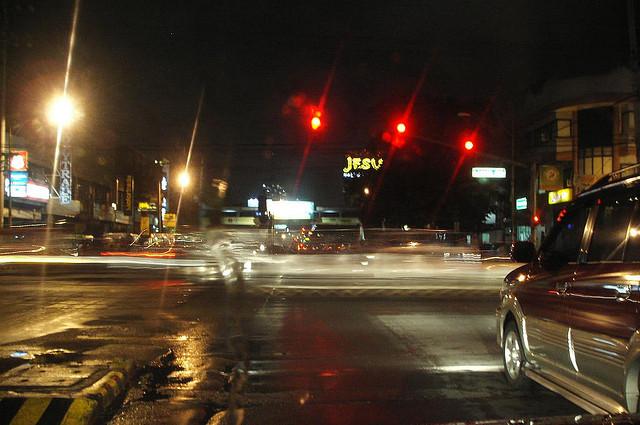What color is the traffic signal?
Answer briefly. Red. Are there any cars on the road?
Be succinct. Yes. Is it raining?
Write a very short answer. Yes. 